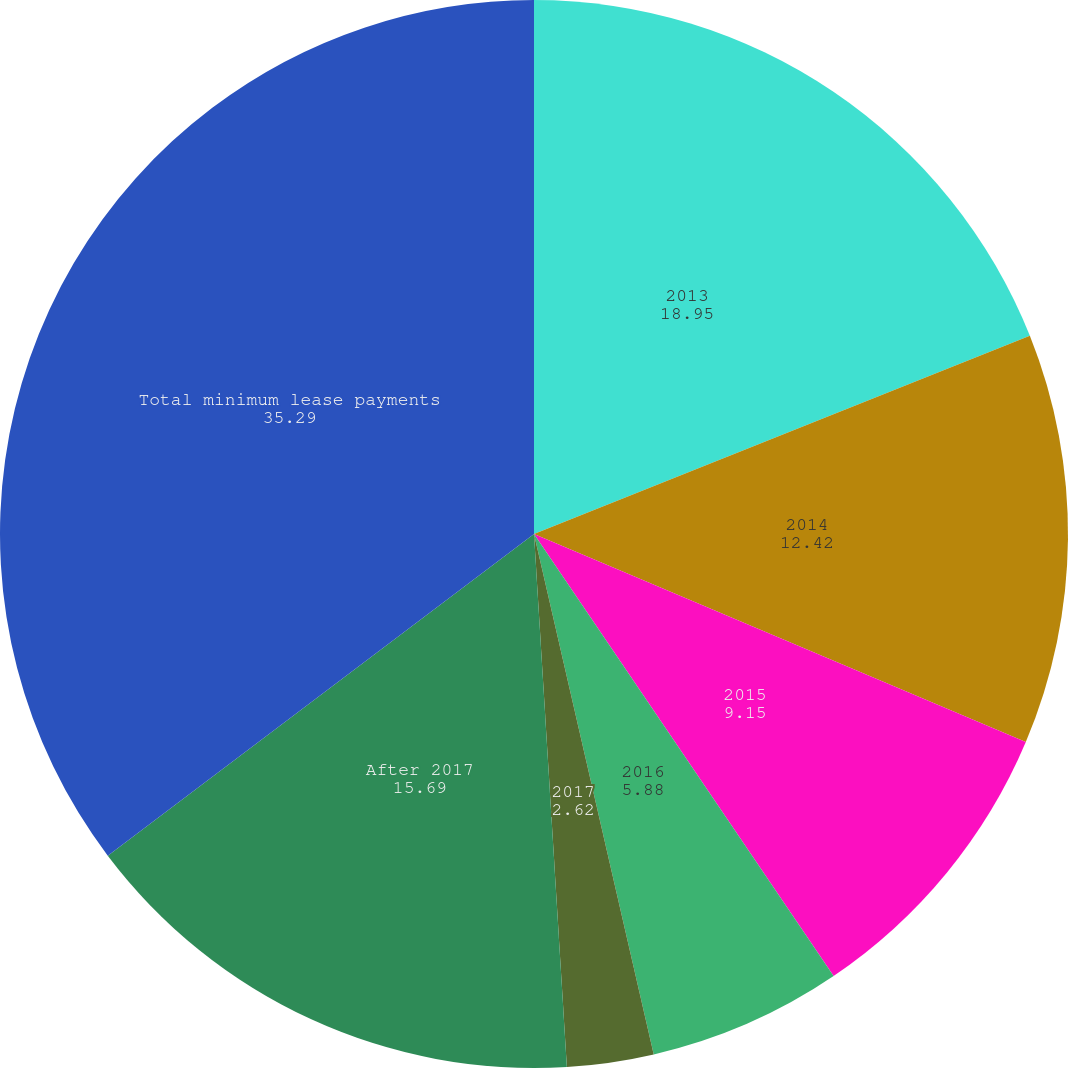<chart> <loc_0><loc_0><loc_500><loc_500><pie_chart><fcel>2013<fcel>2014<fcel>2015<fcel>2016<fcel>2017<fcel>After 2017<fcel>Total minimum lease payments<nl><fcel>18.95%<fcel>12.42%<fcel>9.15%<fcel>5.88%<fcel>2.62%<fcel>15.69%<fcel>35.29%<nl></chart> 